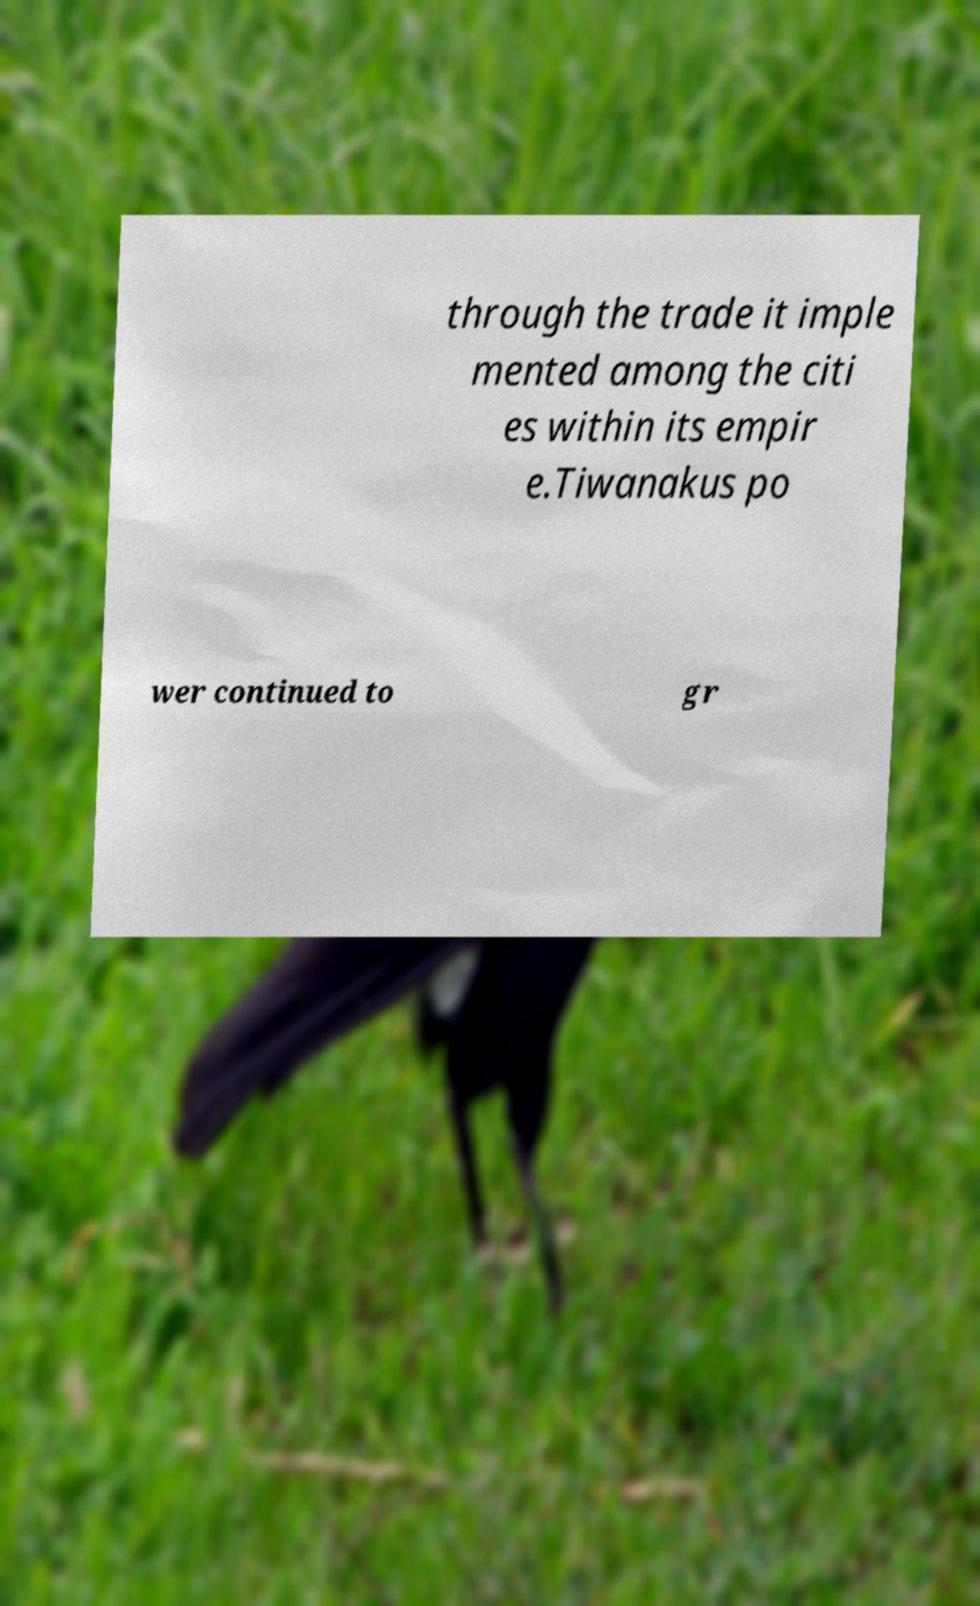What messages or text are displayed in this image? I need them in a readable, typed format. through the trade it imple mented among the citi es within its empir e.Tiwanakus po wer continued to gr 